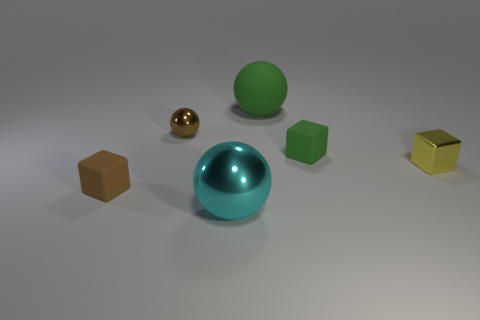Subtract all small green blocks. How many blocks are left? 2 Add 3 cyan cylinders. How many objects exist? 9 Subtract all brown cubes. How many cubes are left? 2 Add 3 small brown cubes. How many small brown cubes exist? 4 Subtract 0 cyan cylinders. How many objects are left? 6 Subtract 1 balls. How many balls are left? 2 Subtract all green spheres. Subtract all red cylinders. How many spheres are left? 2 Subtract all purple cylinders. How many yellow blocks are left? 1 Subtract all small brown things. Subtract all tiny brown shiny objects. How many objects are left? 3 Add 5 big green spheres. How many big green spheres are left? 6 